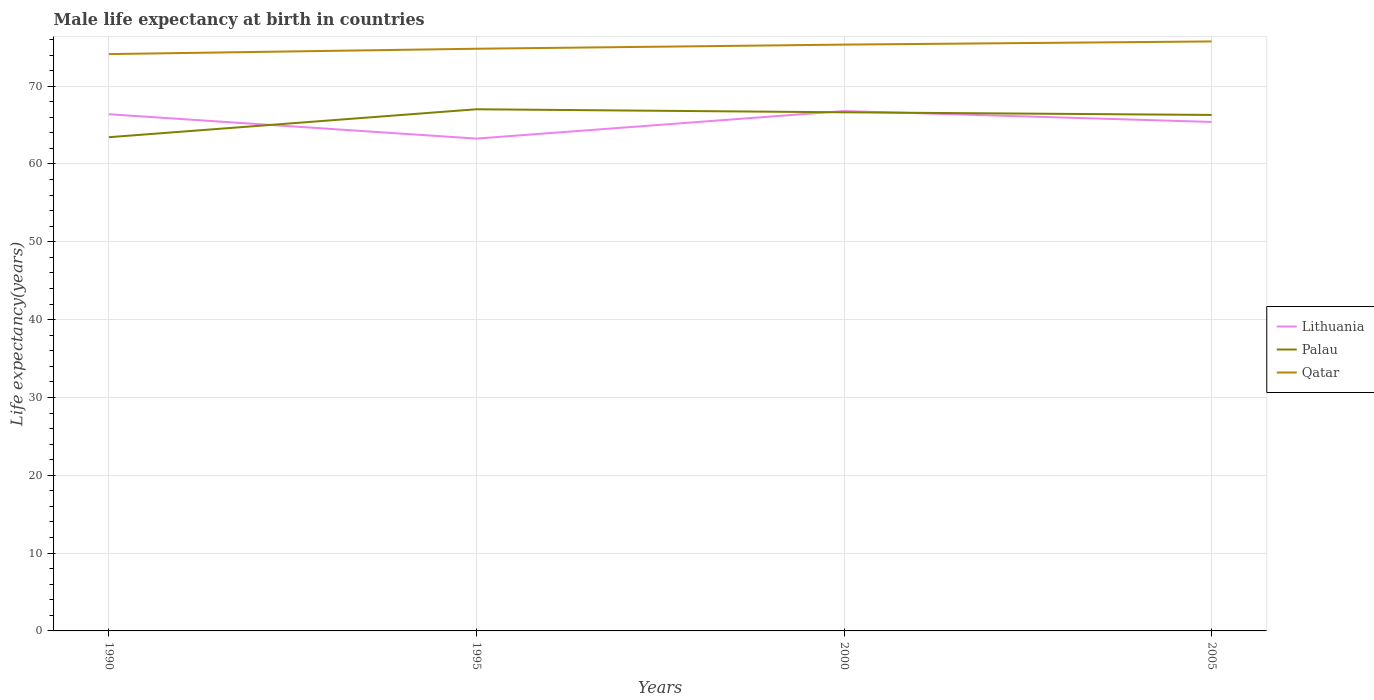Does the line corresponding to Palau intersect with the line corresponding to Qatar?
Provide a short and direct response. No. Is the number of lines equal to the number of legend labels?
Offer a terse response. Yes. Across all years, what is the maximum male life expectancy at birth in Qatar?
Your response must be concise. 74.12. In which year was the male life expectancy at birth in Palau maximum?
Give a very brief answer. 1990. What is the total male life expectancy at birth in Palau in the graph?
Provide a short and direct response. 0.73. What is the difference between the highest and the second highest male life expectancy at birth in Palau?
Provide a succinct answer. 3.59. Is the male life expectancy at birth in Qatar strictly greater than the male life expectancy at birth in Palau over the years?
Keep it short and to the point. No. How many lines are there?
Offer a terse response. 3. How many years are there in the graph?
Ensure brevity in your answer.  4. Are the values on the major ticks of Y-axis written in scientific E-notation?
Your answer should be compact. No. Does the graph contain grids?
Offer a terse response. Yes. Where does the legend appear in the graph?
Ensure brevity in your answer.  Center right. How many legend labels are there?
Give a very brief answer. 3. How are the legend labels stacked?
Make the answer very short. Vertical. What is the title of the graph?
Provide a short and direct response. Male life expectancy at birth in countries. What is the label or title of the Y-axis?
Make the answer very short. Life expectancy(years). What is the Life expectancy(years) of Lithuania in 1990?
Give a very brief answer. 66.39. What is the Life expectancy(years) in Palau in 1990?
Provide a short and direct response. 63.44. What is the Life expectancy(years) in Qatar in 1990?
Keep it short and to the point. 74.12. What is the Life expectancy(years) in Lithuania in 1995?
Provide a succinct answer. 63.26. What is the Life expectancy(years) in Palau in 1995?
Provide a succinct answer. 67.03. What is the Life expectancy(years) in Qatar in 1995?
Keep it short and to the point. 74.81. What is the Life expectancy(years) of Lithuania in 2000?
Offer a terse response. 66.8. What is the Life expectancy(years) in Palau in 2000?
Make the answer very short. 66.64. What is the Life expectancy(years) of Qatar in 2000?
Offer a very short reply. 75.34. What is the Life expectancy(years) in Lithuania in 2005?
Ensure brevity in your answer.  65.4. What is the Life expectancy(years) in Palau in 2005?
Provide a short and direct response. 66.3. What is the Life expectancy(years) of Qatar in 2005?
Keep it short and to the point. 75.75. Across all years, what is the maximum Life expectancy(years) of Lithuania?
Keep it short and to the point. 66.8. Across all years, what is the maximum Life expectancy(years) of Palau?
Your response must be concise. 67.03. Across all years, what is the maximum Life expectancy(years) of Qatar?
Make the answer very short. 75.75. Across all years, what is the minimum Life expectancy(years) of Lithuania?
Provide a succinct answer. 63.26. Across all years, what is the minimum Life expectancy(years) in Palau?
Provide a short and direct response. 63.44. Across all years, what is the minimum Life expectancy(years) of Qatar?
Offer a very short reply. 74.12. What is the total Life expectancy(years) in Lithuania in the graph?
Your answer should be compact. 261.85. What is the total Life expectancy(years) in Palau in the graph?
Offer a terse response. 263.41. What is the total Life expectancy(years) of Qatar in the graph?
Make the answer very short. 300.01. What is the difference between the Life expectancy(years) in Lithuania in 1990 and that in 1995?
Offer a very short reply. 3.13. What is the difference between the Life expectancy(years) in Palau in 1990 and that in 1995?
Keep it short and to the point. -3.59. What is the difference between the Life expectancy(years) in Qatar in 1990 and that in 1995?
Offer a very short reply. -0.69. What is the difference between the Life expectancy(years) of Lithuania in 1990 and that in 2000?
Your answer should be compact. -0.41. What is the difference between the Life expectancy(years) in Qatar in 1990 and that in 2000?
Make the answer very short. -1.22. What is the difference between the Life expectancy(years) of Lithuania in 1990 and that in 2005?
Offer a terse response. 0.99. What is the difference between the Life expectancy(years) of Palau in 1990 and that in 2005?
Your answer should be very brief. -2.86. What is the difference between the Life expectancy(years) in Qatar in 1990 and that in 2005?
Offer a terse response. -1.63. What is the difference between the Life expectancy(years) of Lithuania in 1995 and that in 2000?
Your response must be concise. -3.54. What is the difference between the Life expectancy(years) in Palau in 1995 and that in 2000?
Make the answer very short. 0.39. What is the difference between the Life expectancy(years) in Qatar in 1995 and that in 2000?
Ensure brevity in your answer.  -0.53. What is the difference between the Life expectancy(years) in Lithuania in 1995 and that in 2005?
Give a very brief answer. -2.14. What is the difference between the Life expectancy(years) of Palau in 1995 and that in 2005?
Your answer should be compact. 0.73. What is the difference between the Life expectancy(years) in Qatar in 1995 and that in 2005?
Your answer should be compact. -0.94. What is the difference between the Life expectancy(years) in Lithuania in 2000 and that in 2005?
Your response must be concise. 1.4. What is the difference between the Life expectancy(years) in Palau in 2000 and that in 2005?
Offer a very short reply. 0.34. What is the difference between the Life expectancy(years) in Qatar in 2000 and that in 2005?
Your response must be concise. -0.41. What is the difference between the Life expectancy(years) of Lithuania in 1990 and the Life expectancy(years) of Palau in 1995?
Provide a short and direct response. -0.64. What is the difference between the Life expectancy(years) in Lithuania in 1990 and the Life expectancy(years) in Qatar in 1995?
Offer a very short reply. -8.42. What is the difference between the Life expectancy(years) of Palau in 1990 and the Life expectancy(years) of Qatar in 1995?
Give a very brief answer. -11.37. What is the difference between the Life expectancy(years) in Lithuania in 1990 and the Life expectancy(years) in Palau in 2000?
Your answer should be very brief. -0.25. What is the difference between the Life expectancy(years) of Lithuania in 1990 and the Life expectancy(years) of Qatar in 2000?
Keep it short and to the point. -8.95. What is the difference between the Life expectancy(years) in Palau in 1990 and the Life expectancy(years) in Qatar in 2000?
Provide a succinct answer. -11.9. What is the difference between the Life expectancy(years) in Lithuania in 1990 and the Life expectancy(years) in Palau in 2005?
Make the answer very short. 0.09. What is the difference between the Life expectancy(years) in Lithuania in 1990 and the Life expectancy(years) in Qatar in 2005?
Ensure brevity in your answer.  -9.36. What is the difference between the Life expectancy(years) of Palau in 1990 and the Life expectancy(years) of Qatar in 2005?
Your response must be concise. -12.3. What is the difference between the Life expectancy(years) in Lithuania in 1995 and the Life expectancy(years) in Palau in 2000?
Offer a terse response. -3.38. What is the difference between the Life expectancy(years) of Lithuania in 1995 and the Life expectancy(years) of Qatar in 2000?
Give a very brief answer. -12.08. What is the difference between the Life expectancy(years) of Palau in 1995 and the Life expectancy(years) of Qatar in 2000?
Keep it short and to the point. -8.31. What is the difference between the Life expectancy(years) in Lithuania in 1995 and the Life expectancy(years) in Palau in 2005?
Keep it short and to the point. -3.04. What is the difference between the Life expectancy(years) of Lithuania in 1995 and the Life expectancy(years) of Qatar in 2005?
Provide a succinct answer. -12.48. What is the difference between the Life expectancy(years) in Palau in 1995 and the Life expectancy(years) in Qatar in 2005?
Provide a succinct answer. -8.71. What is the difference between the Life expectancy(years) in Lithuania in 2000 and the Life expectancy(years) in Qatar in 2005?
Your answer should be compact. -8.95. What is the difference between the Life expectancy(years) of Palau in 2000 and the Life expectancy(years) of Qatar in 2005?
Offer a very short reply. -9.11. What is the average Life expectancy(years) of Lithuania per year?
Offer a very short reply. 65.46. What is the average Life expectancy(years) in Palau per year?
Offer a very short reply. 65.85. What is the average Life expectancy(years) in Qatar per year?
Provide a short and direct response. 75. In the year 1990, what is the difference between the Life expectancy(years) in Lithuania and Life expectancy(years) in Palau?
Give a very brief answer. 2.95. In the year 1990, what is the difference between the Life expectancy(years) in Lithuania and Life expectancy(years) in Qatar?
Provide a short and direct response. -7.73. In the year 1990, what is the difference between the Life expectancy(years) in Palau and Life expectancy(years) in Qatar?
Offer a very short reply. -10.68. In the year 1995, what is the difference between the Life expectancy(years) in Lithuania and Life expectancy(years) in Palau?
Offer a very short reply. -3.77. In the year 1995, what is the difference between the Life expectancy(years) in Lithuania and Life expectancy(years) in Qatar?
Ensure brevity in your answer.  -11.55. In the year 1995, what is the difference between the Life expectancy(years) in Palau and Life expectancy(years) in Qatar?
Give a very brief answer. -7.78. In the year 2000, what is the difference between the Life expectancy(years) of Lithuania and Life expectancy(years) of Palau?
Provide a succinct answer. 0.16. In the year 2000, what is the difference between the Life expectancy(years) in Lithuania and Life expectancy(years) in Qatar?
Your answer should be compact. -8.54. In the year 2000, what is the difference between the Life expectancy(years) in Palau and Life expectancy(years) in Qatar?
Offer a very short reply. -8.7. In the year 2005, what is the difference between the Life expectancy(years) of Lithuania and Life expectancy(years) of Qatar?
Your answer should be compact. -10.35. In the year 2005, what is the difference between the Life expectancy(years) of Palau and Life expectancy(years) of Qatar?
Ensure brevity in your answer.  -9.45. What is the ratio of the Life expectancy(years) in Lithuania in 1990 to that in 1995?
Provide a succinct answer. 1.05. What is the ratio of the Life expectancy(years) in Palau in 1990 to that in 1995?
Your answer should be very brief. 0.95. What is the ratio of the Life expectancy(years) in Qatar in 1990 to that in 2000?
Offer a terse response. 0.98. What is the ratio of the Life expectancy(years) of Lithuania in 1990 to that in 2005?
Your response must be concise. 1.02. What is the ratio of the Life expectancy(years) of Palau in 1990 to that in 2005?
Provide a short and direct response. 0.96. What is the ratio of the Life expectancy(years) in Qatar in 1990 to that in 2005?
Your answer should be very brief. 0.98. What is the ratio of the Life expectancy(years) in Lithuania in 1995 to that in 2000?
Your answer should be very brief. 0.95. What is the ratio of the Life expectancy(years) in Palau in 1995 to that in 2000?
Your response must be concise. 1.01. What is the ratio of the Life expectancy(years) of Qatar in 1995 to that in 2000?
Provide a short and direct response. 0.99. What is the ratio of the Life expectancy(years) of Lithuania in 1995 to that in 2005?
Your answer should be compact. 0.97. What is the ratio of the Life expectancy(years) of Palau in 1995 to that in 2005?
Offer a very short reply. 1.01. What is the ratio of the Life expectancy(years) of Qatar in 1995 to that in 2005?
Give a very brief answer. 0.99. What is the ratio of the Life expectancy(years) in Lithuania in 2000 to that in 2005?
Make the answer very short. 1.02. What is the ratio of the Life expectancy(years) of Palau in 2000 to that in 2005?
Your answer should be very brief. 1.01. What is the difference between the highest and the second highest Life expectancy(years) of Lithuania?
Ensure brevity in your answer.  0.41. What is the difference between the highest and the second highest Life expectancy(years) in Palau?
Ensure brevity in your answer.  0.39. What is the difference between the highest and the second highest Life expectancy(years) in Qatar?
Give a very brief answer. 0.41. What is the difference between the highest and the lowest Life expectancy(years) in Lithuania?
Ensure brevity in your answer.  3.54. What is the difference between the highest and the lowest Life expectancy(years) of Palau?
Make the answer very short. 3.59. What is the difference between the highest and the lowest Life expectancy(years) of Qatar?
Offer a terse response. 1.63. 